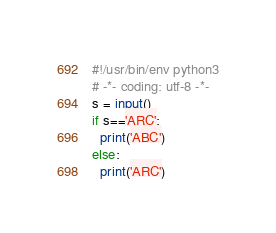<code> <loc_0><loc_0><loc_500><loc_500><_Python_>#!/usr/bin/env python3
# -*- coding: utf-8 -*-
s = input()
if s=='ARC':
  print('ABC')
else:
  print('ARC')
</code> 